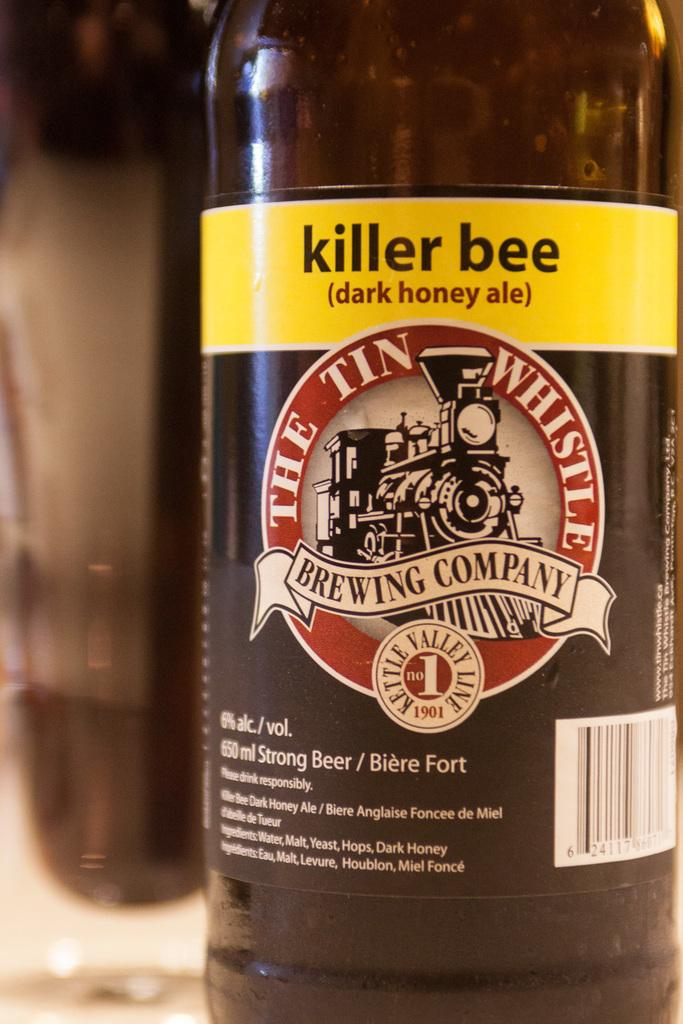<image>
Create a compact narrative representing the image presented. a killer bee bottle that has a train on it 